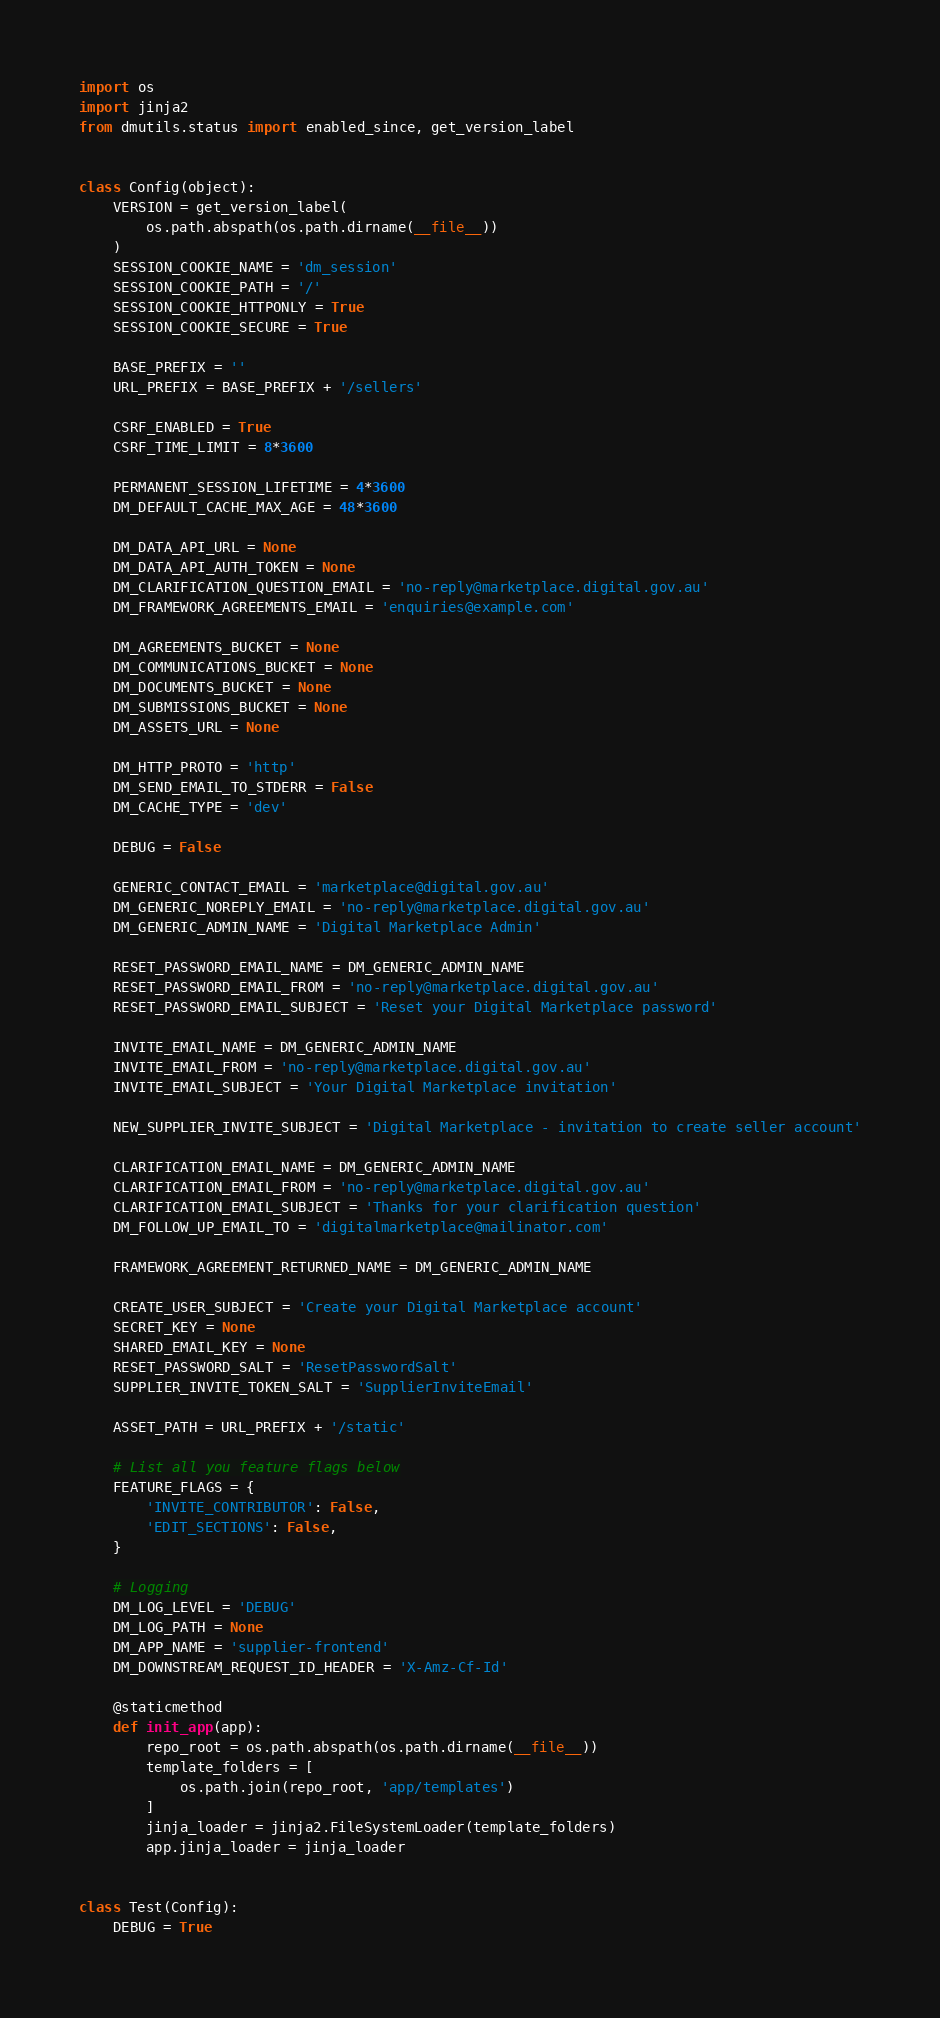<code> <loc_0><loc_0><loc_500><loc_500><_Python_>import os
import jinja2
from dmutils.status import enabled_since, get_version_label


class Config(object):
    VERSION = get_version_label(
        os.path.abspath(os.path.dirname(__file__))
    )
    SESSION_COOKIE_NAME = 'dm_session'
    SESSION_COOKIE_PATH = '/'
    SESSION_COOKIE_HTTPONLY = True
    SESSION_COOKIE_SECURE = True

    BASE_PREFIX = ''
    URL_PREFIX = BASE_PREFIX + '/sellers'

    CSRF_ENABLED = True
    CSRF_TIME_LIMIT = 8*3600

    PERMANENT_SESSION_LIFETIME = 4*3600
    DM_DEFAULT_CACHE_MAX_AGE = 48*3600

    DM_DATA_API_URL = None
    DM_DATA_API_AUTH_TOKEN = None
    DM_CLARIFICATION_QUESTION_EMAIL = 'no-reply@marketplace.digital.gov.au'
    DM_FRAMEWORK_AGREEMENTS_EMAIL = 'enquiries@example.com'

    DM_AGREEMENTS_BUCKET = None
    DM_COMMUNICATIONS_BUCKET = None
    DM_DOCUMENTS_BUCKET = None
    DM_SUBMISSIONS_BUCKET = None
    DM_ASSETS_URL = None

    DM_HTTP_PROTO = 'http'
    DM_SEND_EMAIL_TO_STDERR = False
    DM_CACHE_TYPE = 'dev'

    DEBUG = False

    GENERIC_CONTACT_EMAIL = 'marketplace@digital.gov.au'
    DM_GENERIC_NOREPLY_EMAIL = 'no-reply@marketplace.digital.gov.au'
    DM_GENERIC_ADMIN_NAME = 'Digital Marketplace Admin'

    RESET_PASSWORD_EMAIL_NAME = DM_GENERIC_ADMIN_NAME
    RESET_PASSWORD_EMAIL_FROM = 'no-reply@marketplace.digital.gov.au'
    RESET_PASSWORD_EMAIL_SUBJECT = 'Reset your Digital Marketplace password'

    INVITE_EMAIL_NAME = DM_GENERIC_ADMIN_NAME
    INVITE_EMAIL_FROM = 'no-reply@marketplace.digital.gov.au'
    INVITE_EMAIL_SUBJECT = 'Your Digital Marketplace invitation'

    NEW_SUPPLIER_INVITE_SUBJECT = 'Digital Marketplace - invitation to create seller account'

    CLARIFICATION_EMAIL_NAME = DM_GENERIC_ADMIN_NAME
    CLARIFICATION_EMAIL_FROM = 'no-reply@marketplace.digital.gov.au'
    CLARIFICATION_EMAIL_SUBJECT = 'Thanks for your clarification question'
    DM_FOLLOW_UP_EMAIL_TO = 'digitalmarketplace@mailinator.com'

    FRAMEWORK_AGREEMENT_RETURNED_NAME = DM_GENERIC_ADMIN_NAME

    CREATE_USER_SUBJECT = 'Create your Digital Marketplace account'
    SECRET_KEY = None
    SHARED_EMAIL_KEY = None
    RESET_PASSWORD_SALT = 'ResetPasswordSalt'
    SUPPLIER_INVITE_TOKEN_SALT = 'SupplierInviteEmail'

    ASSET_PATH = URL_PREFIX + '/static'

    # List all you feature flags below
    FEATURE_FLAGS = {
        'INVITE_CONTRIBUTOR': False,
        'EDIT_SECTIONS': False,
    }

    # Logging
    DM_LOG_LEVEL = 'DEBUG'
    DM_LOG_PATH = None
    DM_APP_NAME = 'supplier-frontend'
    DM_DOWNSTREAM_REQUEST_ID_HEADER = 'X-Amz-Cf-Id'

    @staticmethod
    def init_app(app):
        repo_root = os.path.abspath(os.path.dirname(__file__))
        template_folders = [
            os.path.join(repo_root, 'app/templates')
        ]
        jinja_loader = jinja2.FileSystemLoader(template_folders)
        app.jinja_loader = jinja_loader


class Test(Config):
    DEBUG = True</code> 